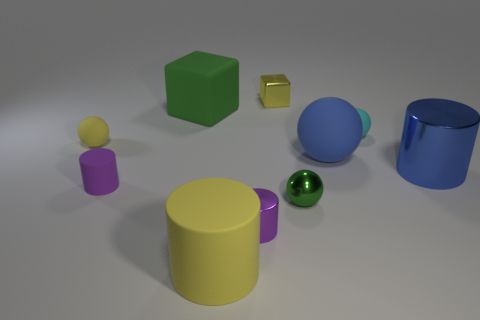Subtract all blue balls. Subtract all blue cubes. How many balls are left? 3 Subtract all cylinders. How many objects are left? 6 Add 9 large purple matte spheres. How many large purple matte spheres exist? 9 Subtract 1 cyan balls. How many objects are left? 9 Subtract all blue objects. Subtract all large green blocks. How many objects are left? 7 Add 7 metallic spheres. How many metallic spheres are left? 8 